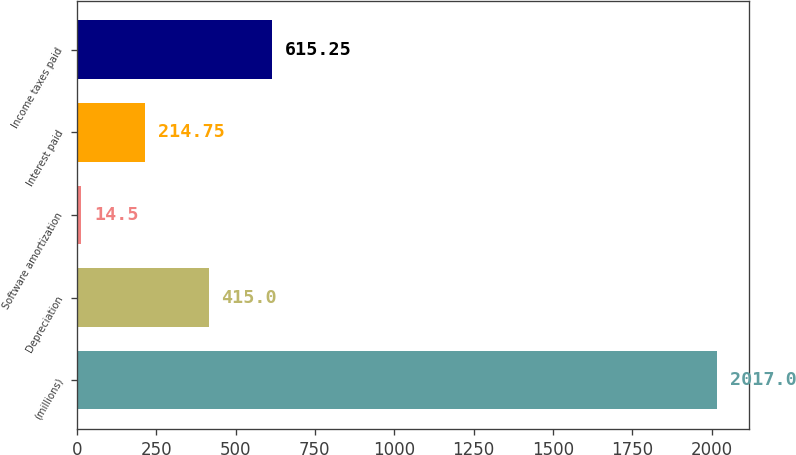Convert chart. <chart><loc_0><loc_0><loc_500><loc_500><bar_chart><fcel>(millions)<fcel>Depreciation<fcel>Software amortization<fcel>Interest paid<fcel>Income taxes paid<nl><fcel>2017<fcel>415<fcel>14.5<fcel>214.75<fcel>615.25<nl></chart> 